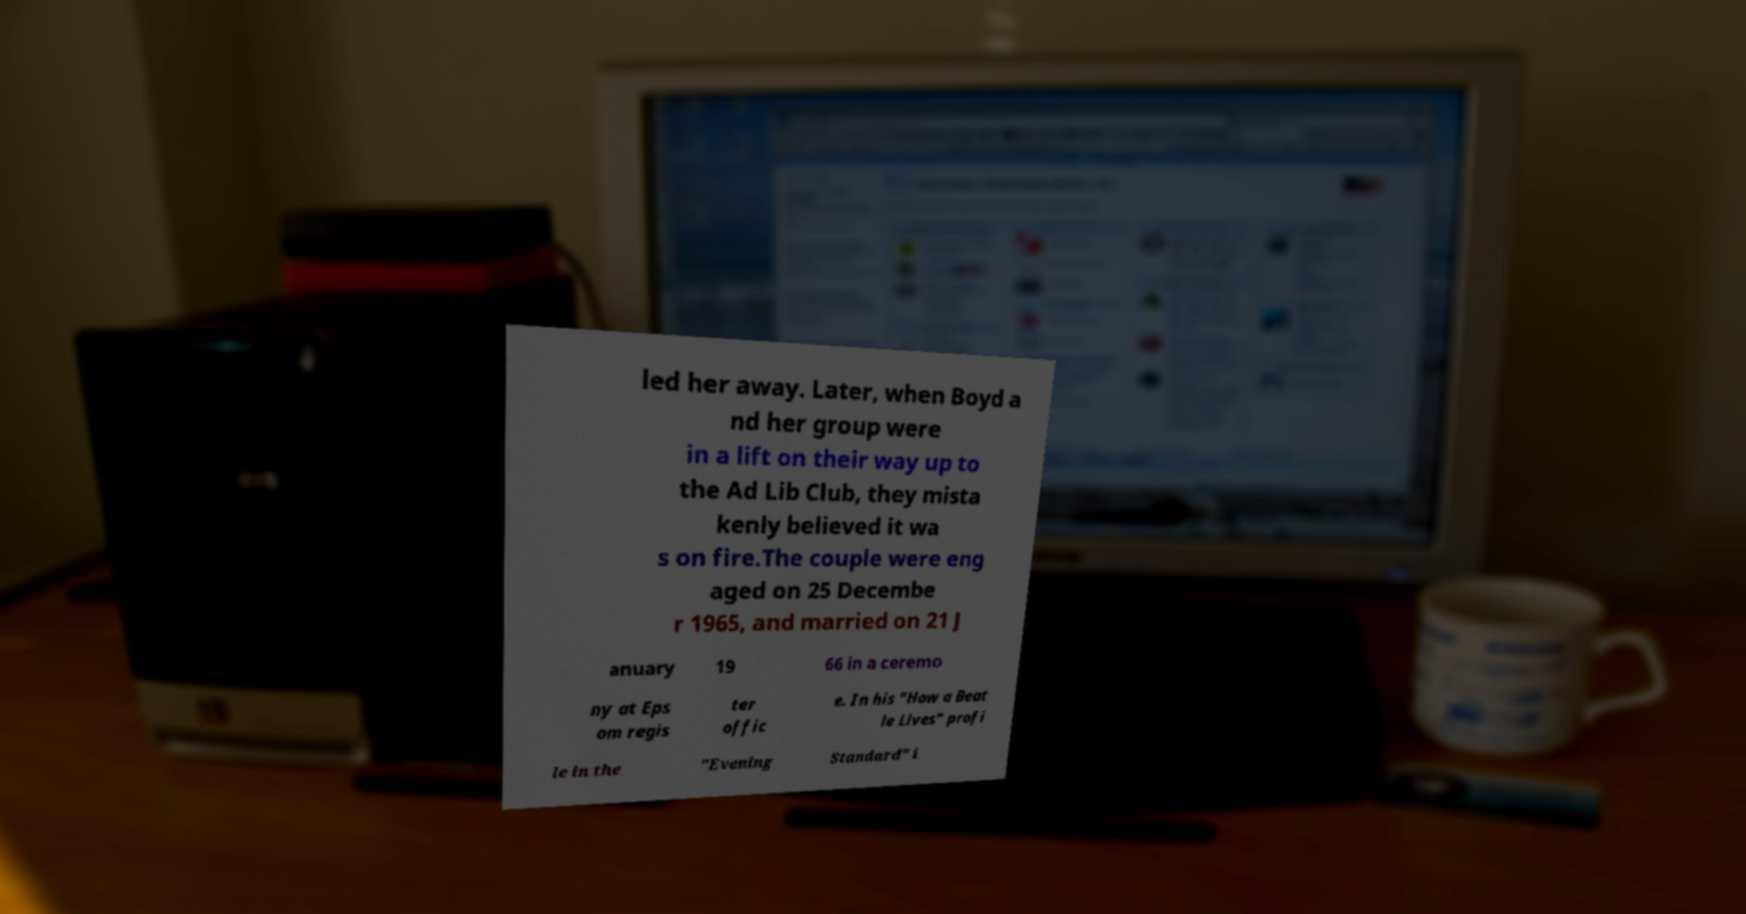Could you extract and type out the text from this image? led her away. Later, when Boyd a nd her group were in a lift on their way up to the Ad Lib Club, they mista kenly believed it wa s on fire.The couple were eng aged on 25 Decembe r 1965, and married on 21 J anuary 19 66 in a ceremo ny at Eps om regis ter offic e. In his "How a Beat le Lives" profi le in the "Evening Standard" i 